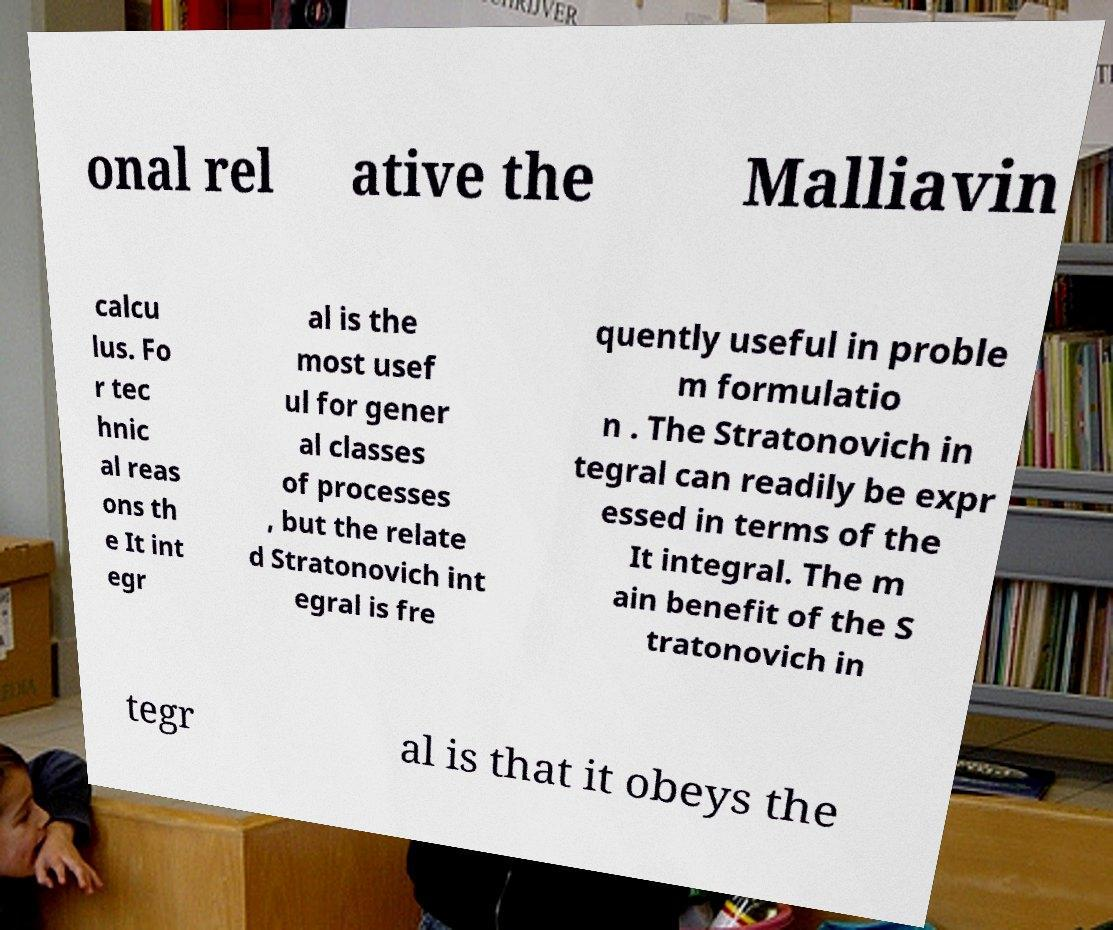For documentation purposes, I need the text within this image transcribed. Could you provide that? onal rel ative the Malliavin calcu lus. Fo r tec hnic al reas ons th e It int egr al is the most usef ul for gener al classes of processes , but the relate d Stratonovich int egral is fre quently useful in proble m formulatio n . The Stratonovich in tegral can readily be expr essed in terms of the It integral. The m ain benefit of the S tratonovich in tegr al is that it obeys the 